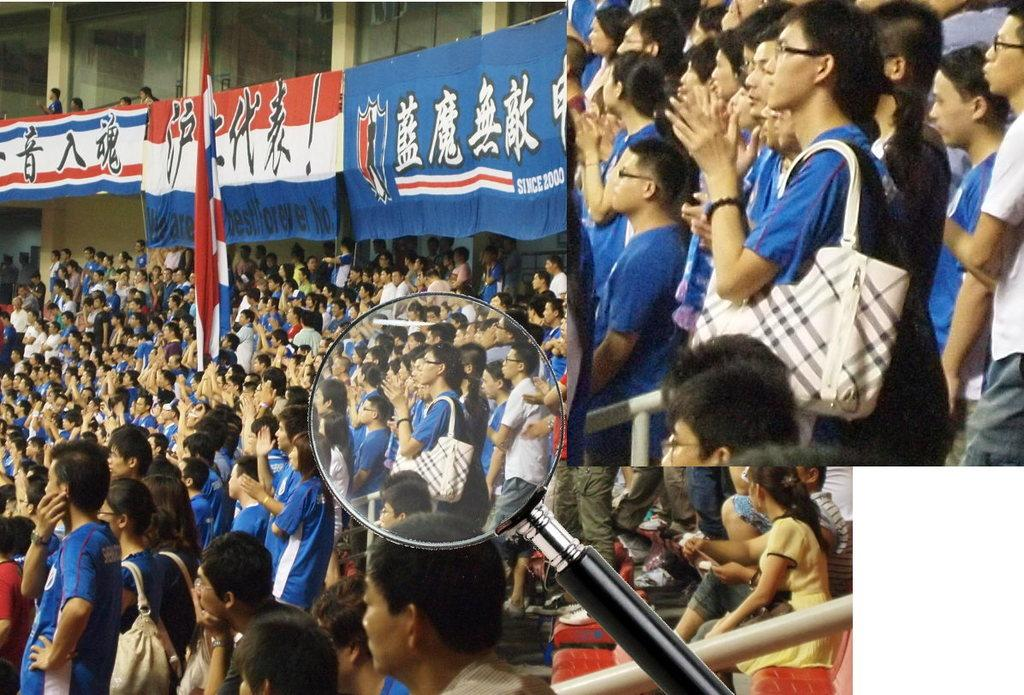What can be observed about the image that suggests it has been edited? The image appears to be edited, but the specific editing techniques or effects are not mentioned in the facts. What object can be seen in the image that is typically used for magnification? There is a magnifying glass in the image. Can you describe the group of people in the image? There is a group of people in the image, but their specific characteristics or actions are not mentioned in the facts. What type of signage is present in the image? There are banners in the image. What national symbol is visible in the image? There is a flag in the image. What type of butter is being used by the people in the image? There is no butter present in the image, and the people's actions or activities are not mentioned in the facts. Can you tell me the name of the uncle who is holding the flag in the image? There is no uncle mentioned in the facts, and the people's relationships to each other are not specified. 